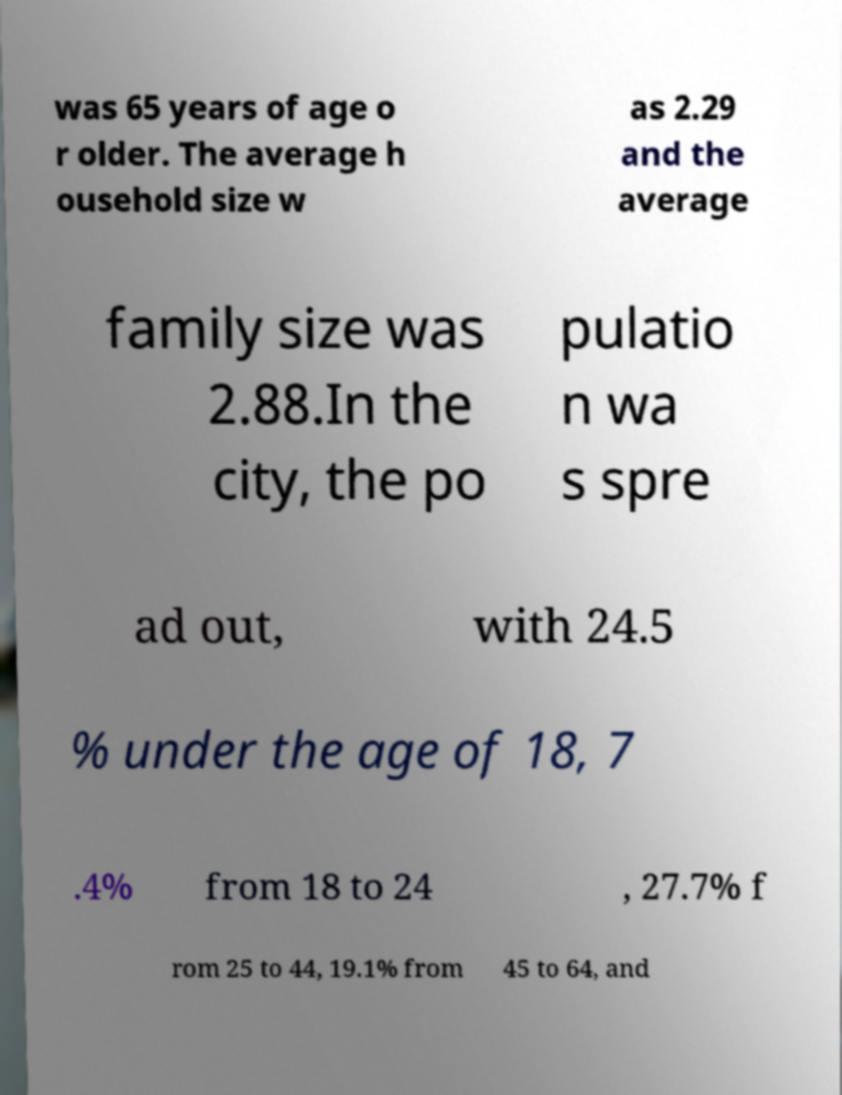Can you read and provide the text displayed in the image?This photo seems to have some interesting text. Can you extract and type it out for me? was 65 years of age o r older. The average h ousehold size w as 2.29 and the average family size was 2.88.In the city, the po pulatio n wa s spre ad out, with 24.5 % under the age of 18, 7 .4% from 18 to 24 , 27.7% f rom 25 to 44, 19.1% from 45 to 64, and 